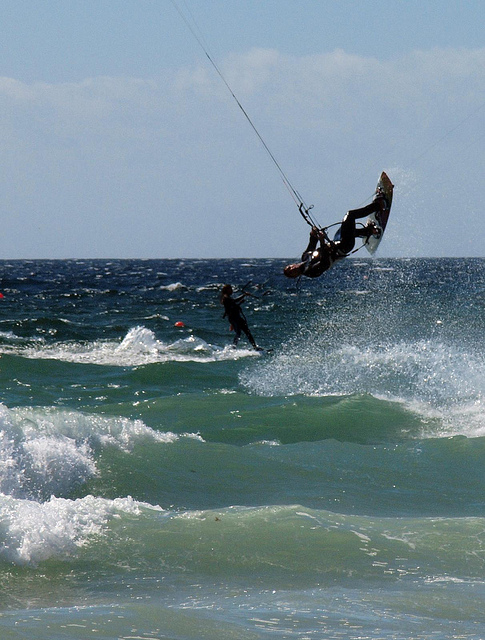<image>Is the water cold? I don't know if the water is cold or not. It can be both cold and not cold. Is the water cold? I don't know if the water is cold. It can be both cold and not cold. 